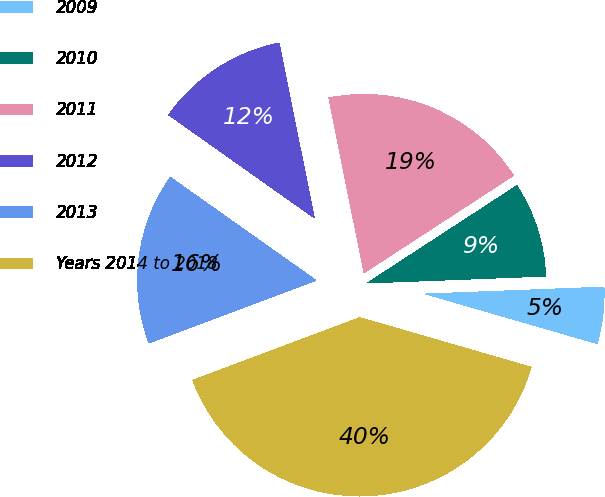Convert chart. <chart><loc_0><loc_0><loc_500><loc_500><pie_chart><fcel>2009<fcel>2010<fcel>2011<fcel>2012<fcel>2013<fcel>Years 2014 to 2018<nl><fcel>5.1%<fcel>8.57%<fcel>18.98%<fcel>12.04%<fcel>15.51%<fcel>39.81%<nl></chart> 